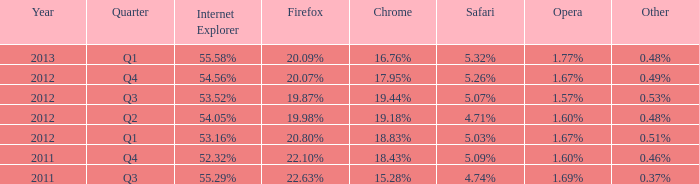What is the alternative that has 2 0.51%. 